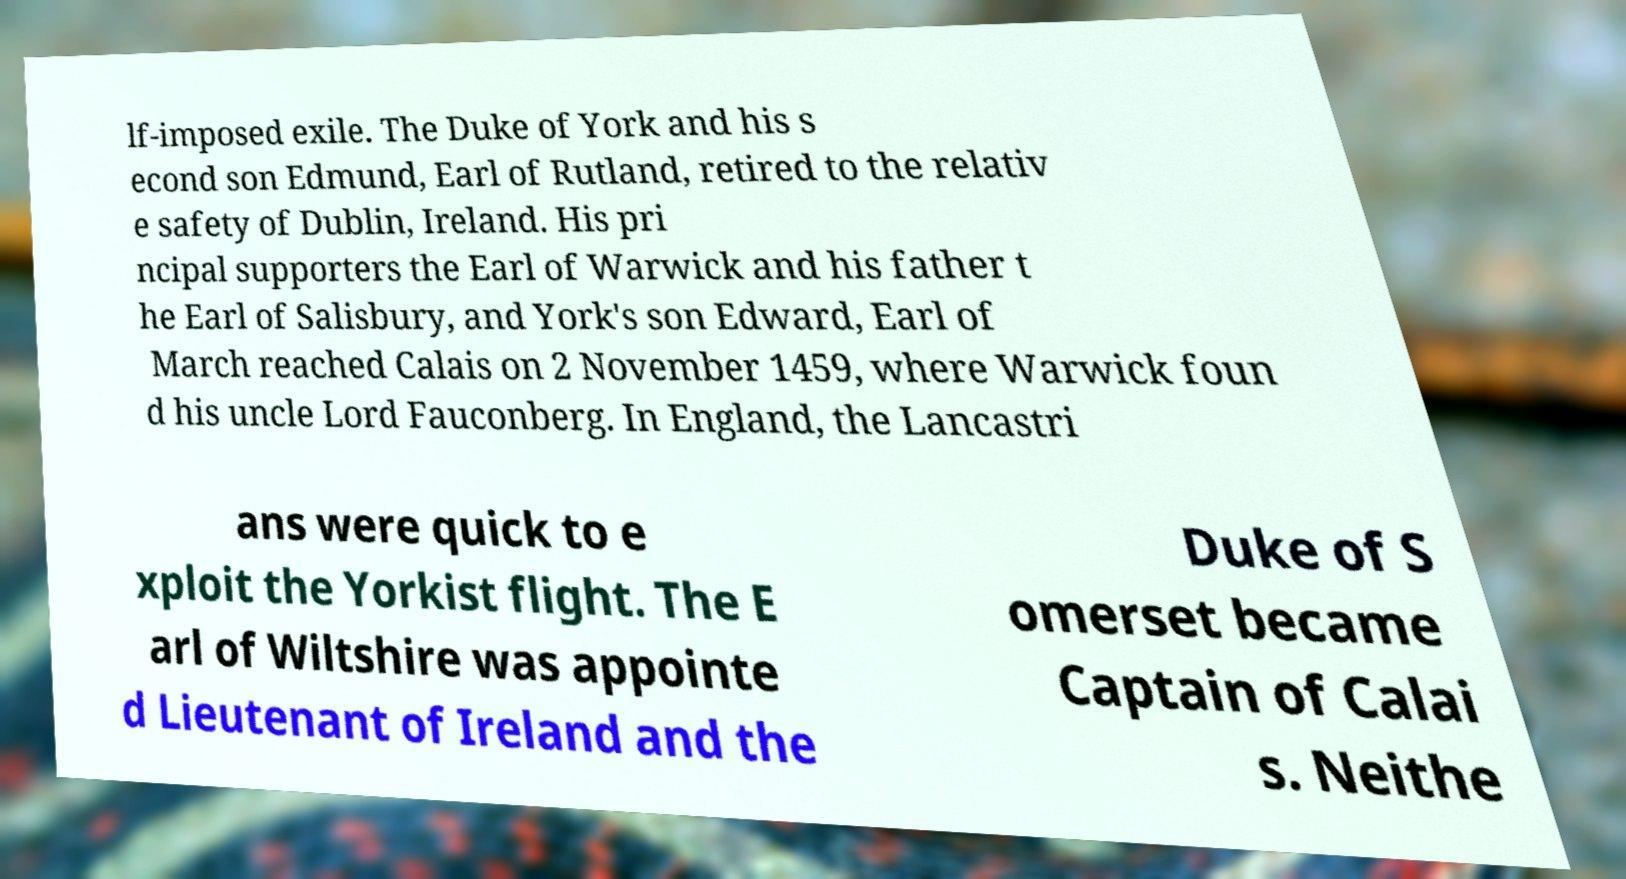Can you read and provide the text displayed in the image?This photo seems to have some interesting text. Can you extract and type it out for me? lf-imposed exile. The Duke of York and his s econd son Edmund, Earl of Rutland, retired to the relativ e safety of Dublin, Ireland. His pri ncipal supporters the Earl of Warwick and his father t he Earl of Salisbury, and York's son Edward, Earl of March reached Calais on 2 November 1459, where Warwick foun d his uncle Lord Fauconberg. In England, the Lancastri ans were quick to e xploit the Yorkist flight. The E arl of Wiltshire was appointe d Lieutenant of Ireland and the Duke of S omerset became Captain of Calai s. Neithe 